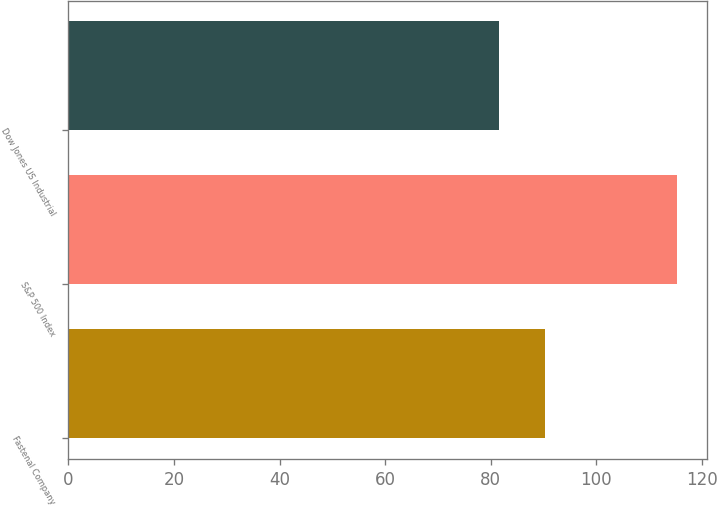Convert chart. <chart><loc_0><loc_0><loc_500><loc_500><bar_chart><fcel>Fastenal Company<fcel>S&P 500 Index<fcel>Dow Jones US Industrial<nl><fcel>90.26<fcel>115.26<fcel>81.47<nl></chart> 